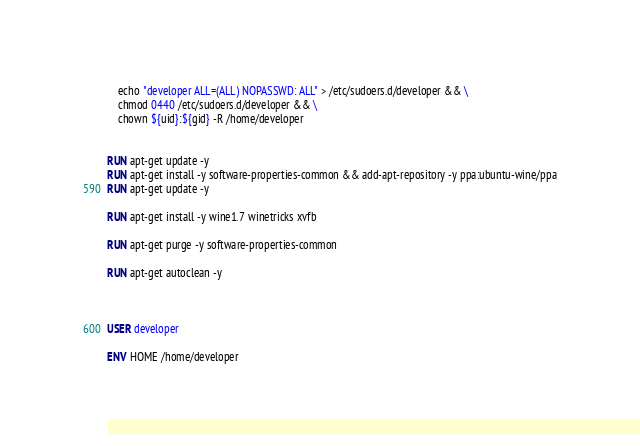Convert code to text. <code><loc_0><loc_0><loc_500><loc_500><_Dockerfile_>    echo "developer ALL=(ALL) NOPASSWD: ALL" > /etc/sudoers.d/developer && \
    chmod 0440 /etc/sudoers.d/developer && \
    chown ${uid}:${gid} -R /home/developer


RUN apt-get update -y
RUN apt-get install -y software-properties-common && add-apt-repository -y ppa:ubuntu-wine/ppa
RUN apt-get update -y

RUN apt-get install -y wine1.7 winetricks xvfb

RUN apt-get purge -y software-properties-common

RUN apt-get autoclean -y



USER developer

ENV HOME /home/developer
</code> 